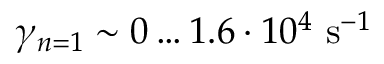Convert formula to latex. <formula><loc_0><loc_0><loc_500><loc_500>{ \gamma _ { n = 1 } \sim 0 \dots 1 . 6 \cdot 1 0 ^ { 4 } s ^ { - 1 } }</formula> 